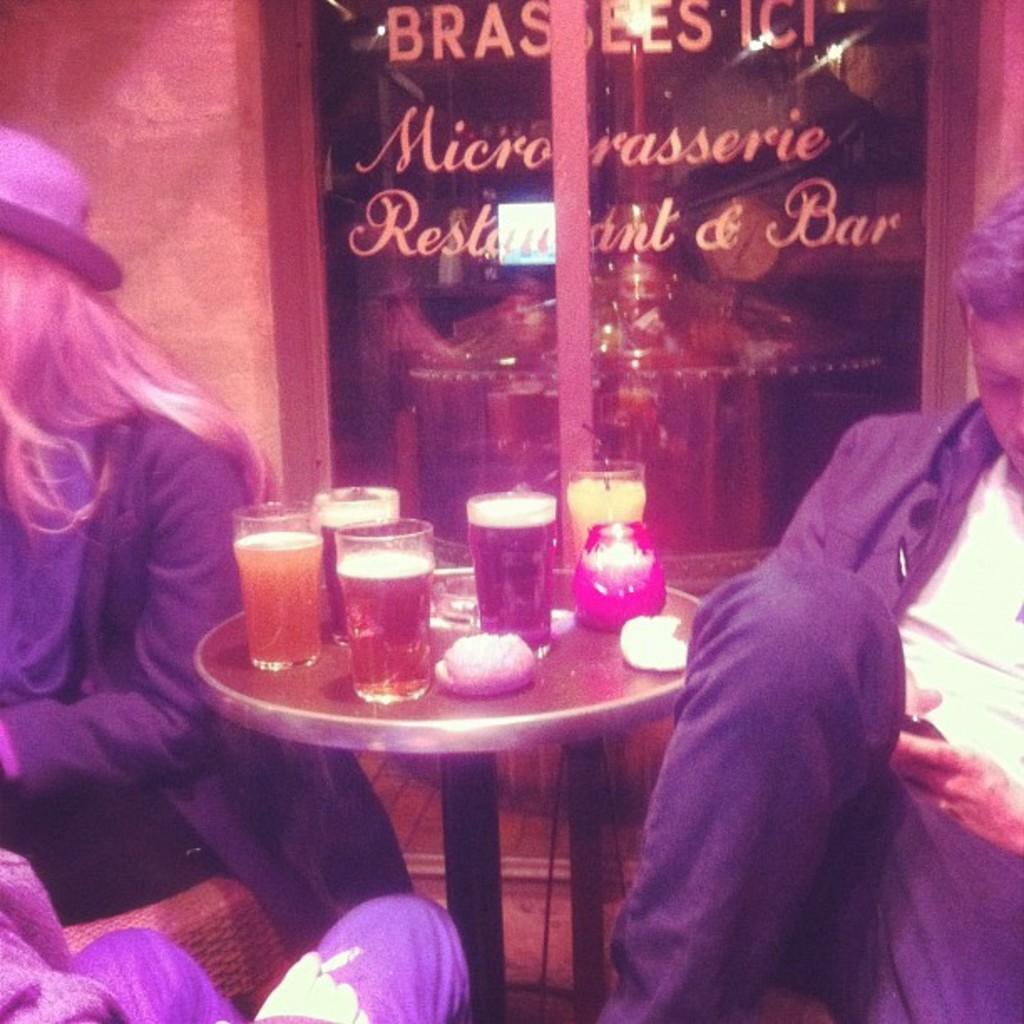What piece of furniture is in the center of the image? There is a table in the image. What is placed on the table? There is a candle and glasses of drinks on the table. How many people are seated around the table? There are three people seated around the table. What are the people sitting on? Each person is seated on a chair. What can be seen in the background of the image? There is a door visible in the background, with "restaurant" and "bar" written on it. How many railway tracks can be seen in the image? There are no railway tracks present in the image. Are there any beds visible in the image? There are no beds present in the image. 